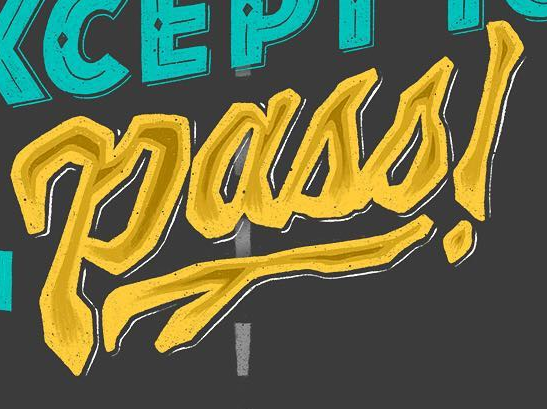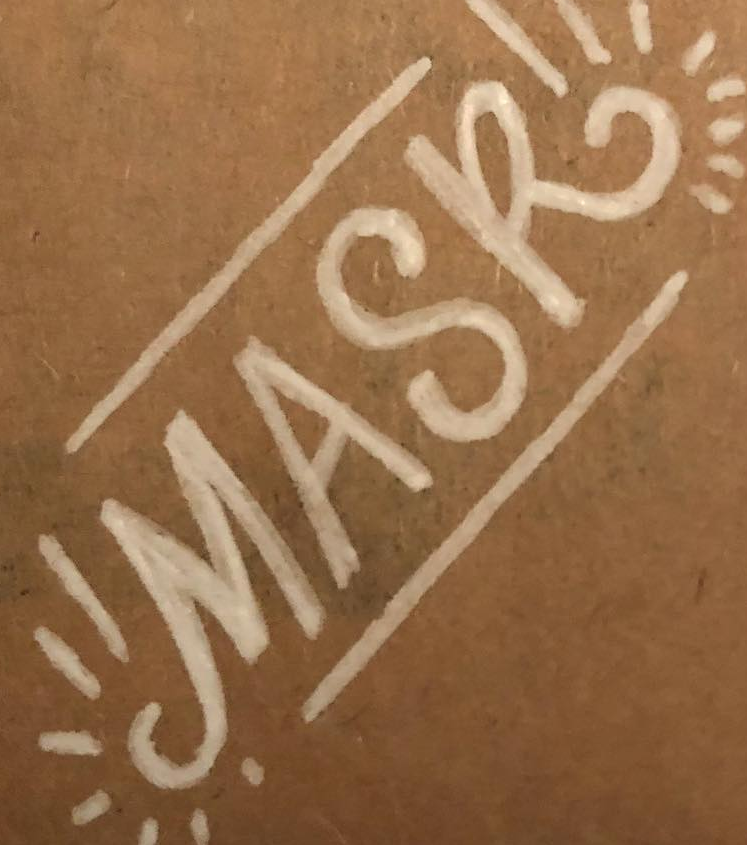Read the text from these images in sequence, separated by a semicolon. Pass!; MASK 